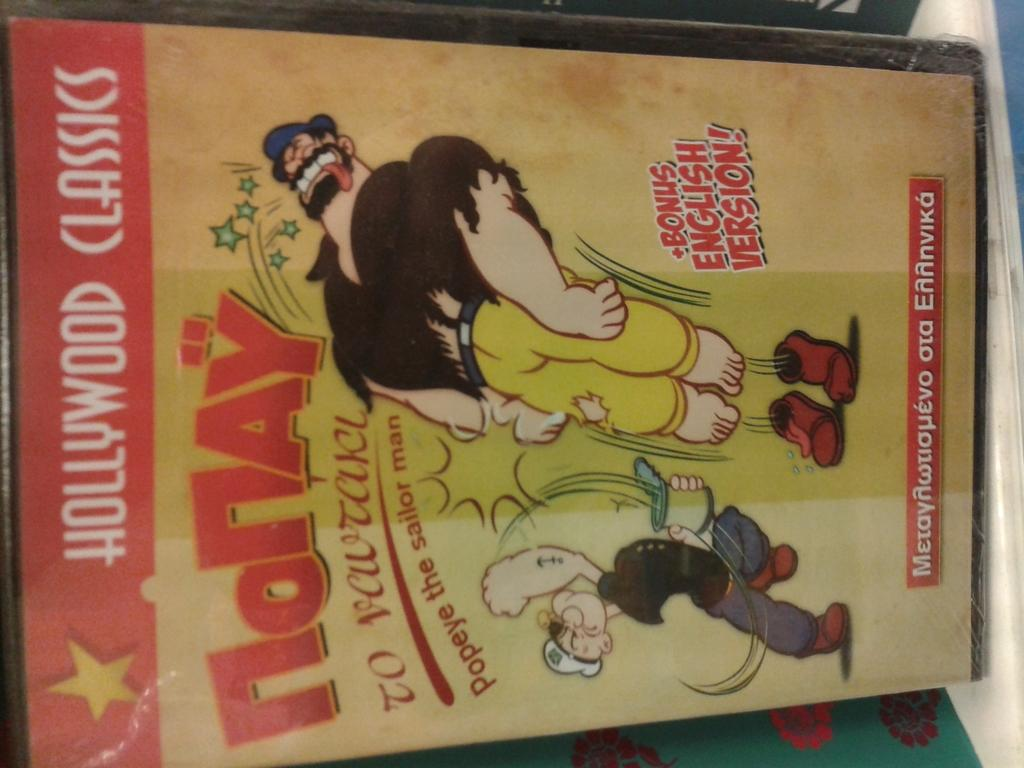<image>
Give a short and clear explanation of the subsequent image. A DVD case for the English Version of the Hollywood Classic popeye is on display 